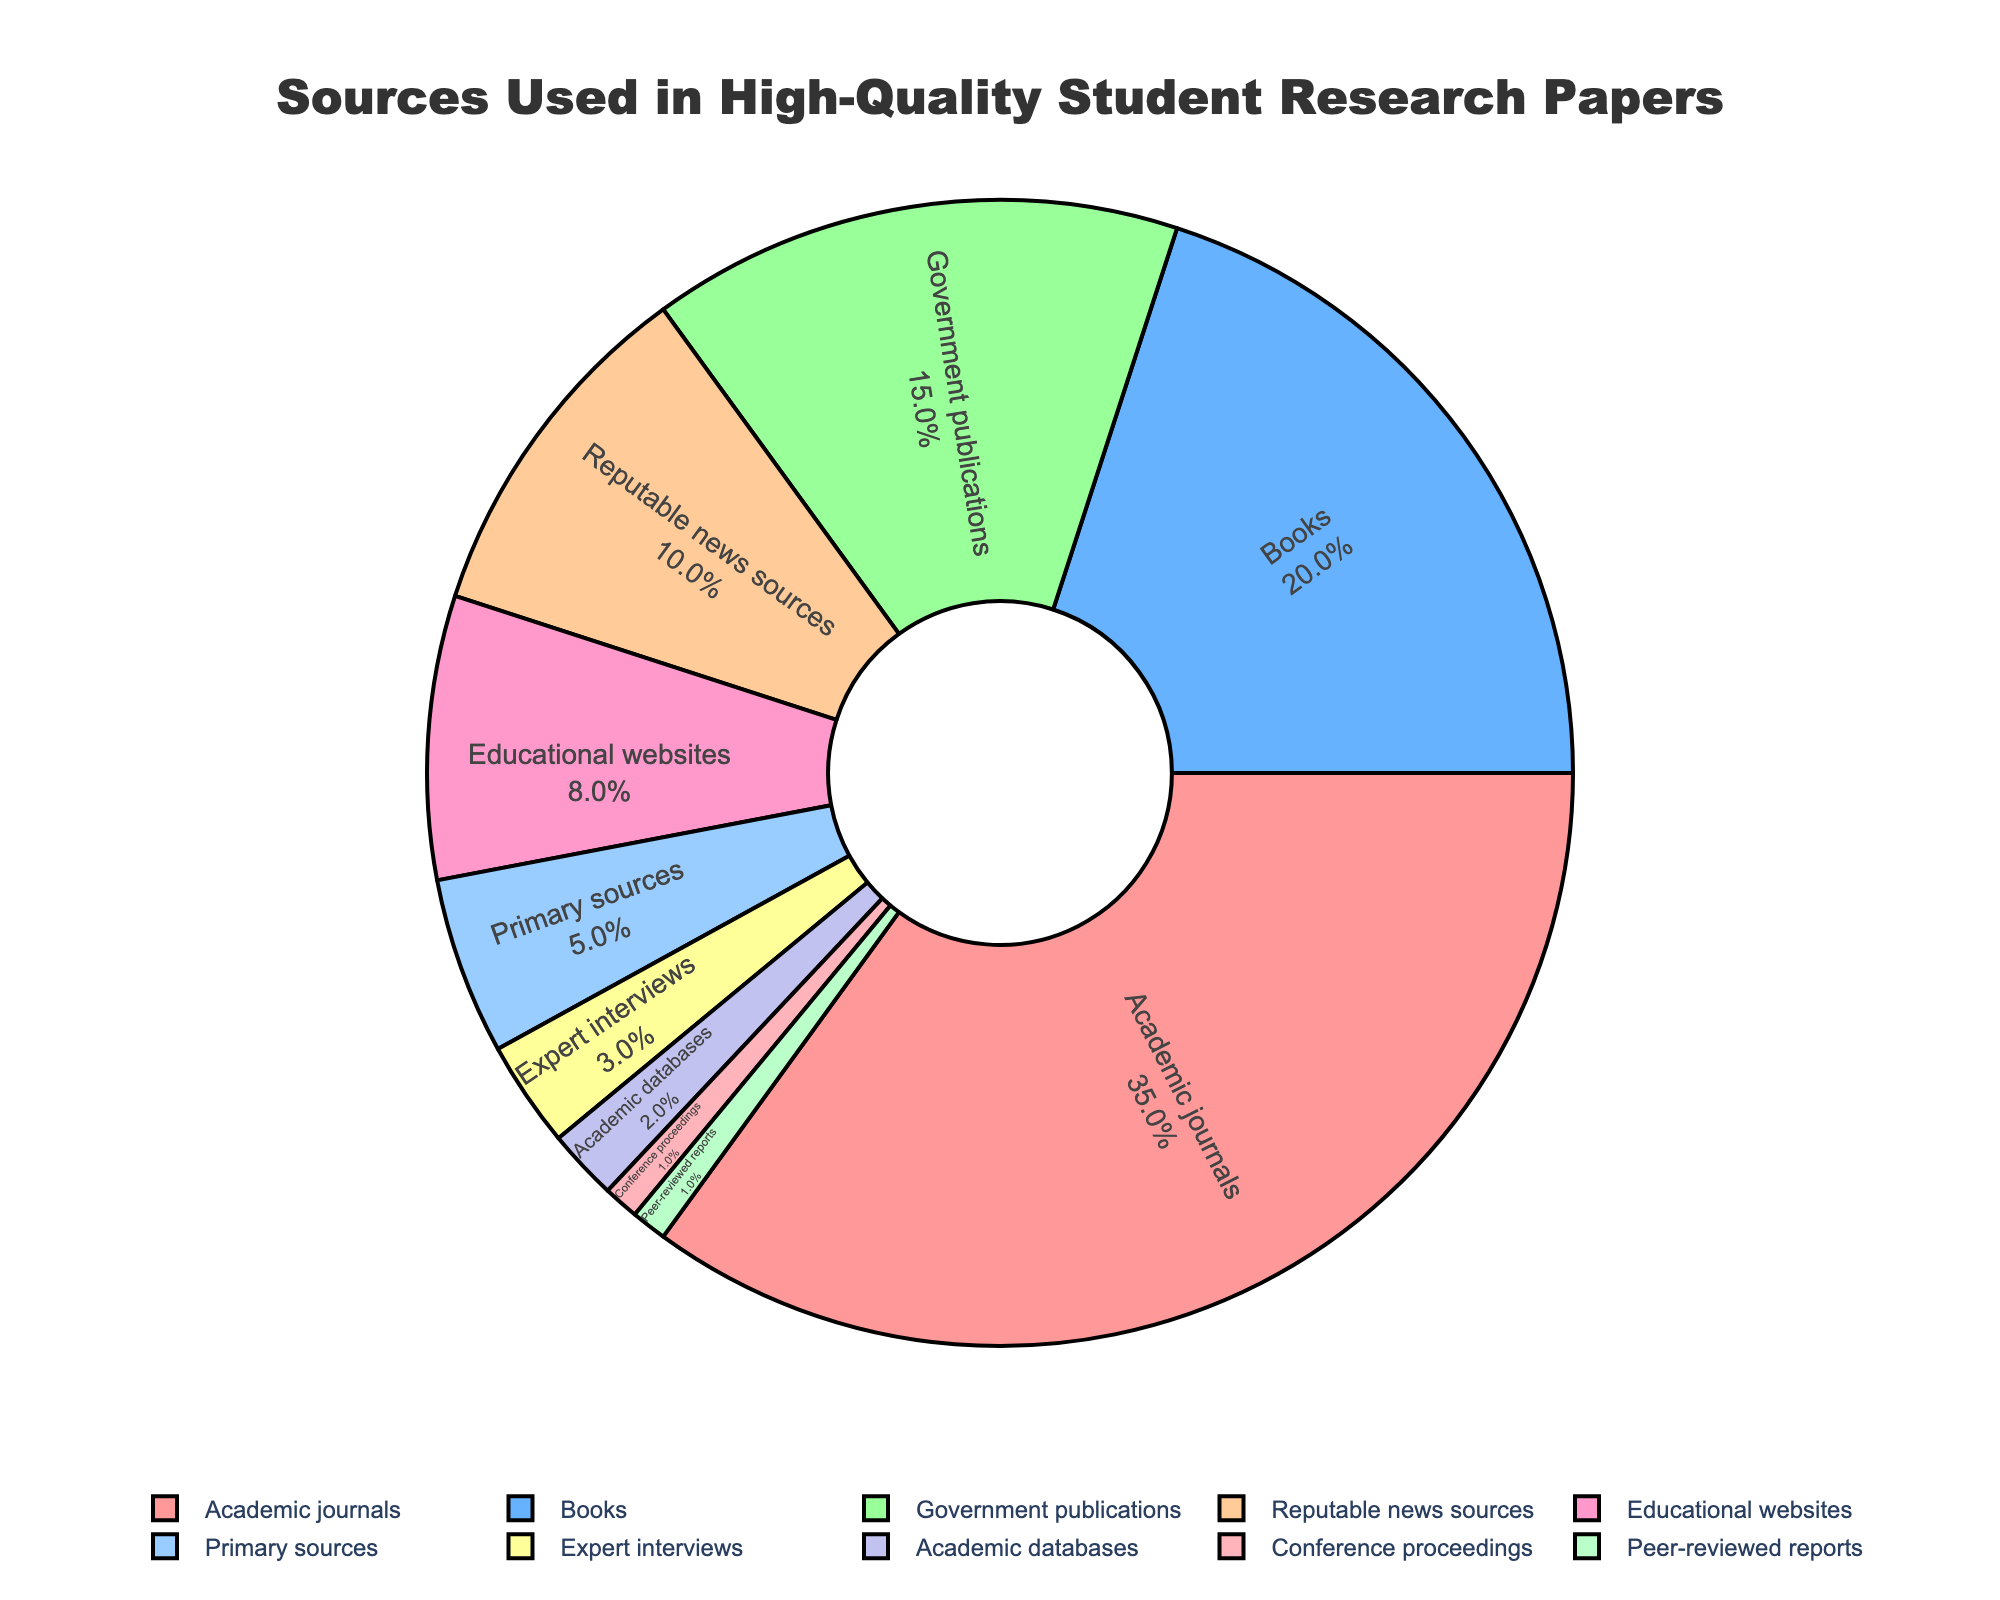What's the most frequently used source in high-quality student research papers? The figure shows that "Academic journals" have the largest section in the pie chart, indicating they are the most frequently used source.
Answer: Academic journals Which source has a higher percentage: government publications or reputable news sources? By comparing the chart sections for "Government publications" and "Reputable news sources", it is clear that "Government publications" have a larger section, meaning a higher percentage.
Answer: Government publications What is the combined percentage of sources classified as educational websites and primary sources? To find the combined percentage, add the percentages of "Educational websites" (8%) and "Primary sources" (5%). So, 8% + 5% = 13%.
Answer: 13% Identify the color associated with books in the pie chart. The section labeled "Books" is colored in the second color appearing in the pie chart, which is blue.
Answer: Blue How much more frequently are academic journals used compared to expert interviews? The percentage for "Academic journals" is 35%, while for "Expert interviews" it is 3%. The difference between them is 35% - 3% = 32%.
Answer: 32% What is the least used source type in high-quality student research papers? The smallest section in the pie chart represents "Conference proceedings" and "Peer-reviewed reports", both having the smallest percentage.
Answer: Conference proceedings and Peer-reviewed reports If you combine the percentages of books, government publications, and reputable news sources, what would be the total? Add the percentages for "Books" (20%), "Government publications" (15%), and "Reputable news sources" (10%). So, 20% + 15% + 10% = 45%.
Answer: 45% Estimate the proportion of non-primary sources as per this pie chart. Non-primary sources include all sources except for "Primary sources". First, sum up all the percentages excluding the primary sources. This totals 95% since "Primary sources" contribute 5%.
Answer: 95% What is the percentage difference between the use of educational websites and academic databases? The chart shows "Educational websites" at 8% and "Academic databases" at 2%. The percentage difference is 8% - 2% = 6%.
Answer: 6% In terms of usage, how do reputable news sources compare with primary sources? "Reputable news sources" account for 10% while "Primary sources" account for 5% of the pie chart. Therefore, reputable news sources are used twice as much as primary sources.
Answer: Twice as much 